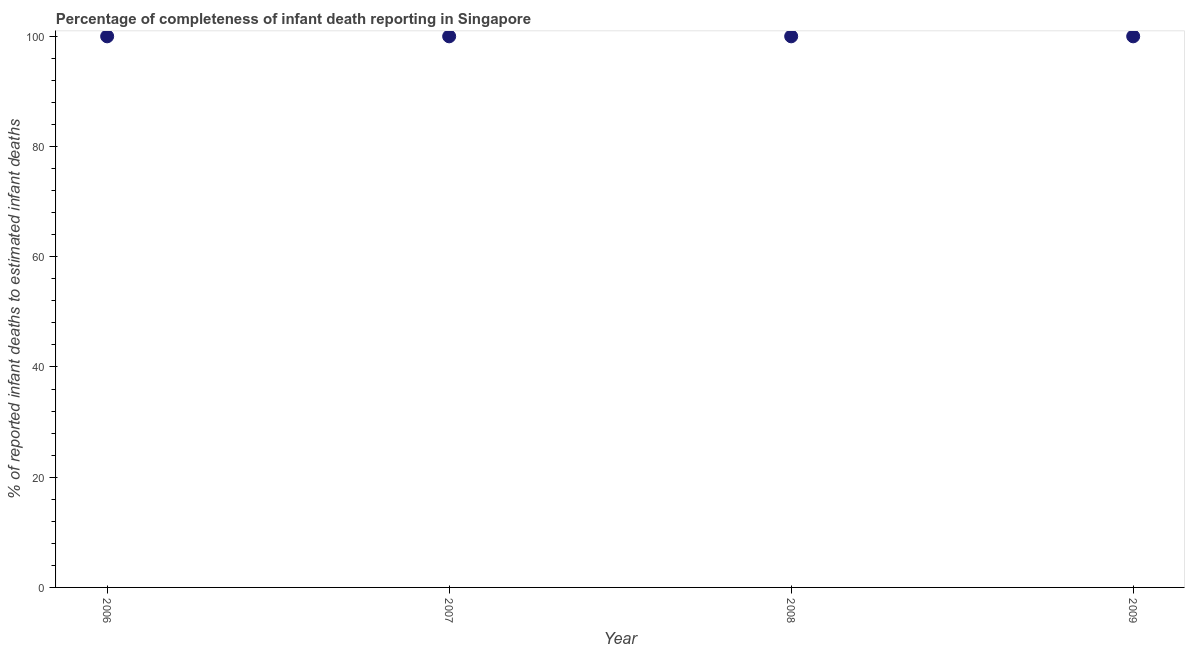What is the completeness of infant death reporting in 2008?
Offer a terse response. 100. Across all years, what is the maximum completeness of infant death reporting?
Your answer should be very brief. 100. Across all years, what is the minimum completeness of infant death reporting?
Provide a short and direct response. 100. In which year was the completeness of infant death reporting maximum?
Keep it short and to the point. 2006. What is the sum of the completeness of infant death reporting?
Make the answer very short. 400. What is the average completeness of infant death reporting per year?
Offer a terse response. 100. Is the difference between the completeness of infant death reporting in 2006 and 2007 greater than the difference between any two years?
Keep it short and to the point. Yes. What is the difference between the highest and the lowest completeness of infant death reporting?
Make the answer very short. 0. How many dotlines are there?
Your answer should be compact. 1. What is the difference between two consecutive major ticks on the Y-axis?
Ensure brevity in your answer.  20. What is the title of the graph?
Offer a terse response. Percentage of completeness of infant death reporting in Singapore. What is the label or title of the X-axis?
Your answer should be very brief. Year. What is the label or title of the Y-axis?
Provide a succinct answer. % of reported infant deaths to estimated infant deaths. What is the % of reported infant deaths to estimated infant deaths in 2008?
Offer a terse response. 100. What is the difference between the % of reported infant deaths to estimated infant deaths in 2006 and 2007?
Offer a very short reply. 0. What is the difference between the % of reported infant deaths to estimated infant deaths in 2006 and 2008?
Give a very brief answer. 0. What is the difference between the % of reported infant deaths to estimated infant deaths in 2006 and 2009?
Ensure brevity in your answer.  0. What is the difference between the % of reported infant deaths to estimated infant deaths in 2007 and 2008?
Keep it short and to the point. 0. What is the ratio of the % of reported infant deaths to estimated infant deaths in 2006 to that in 2007?
Ensure brevity in your answer.  1. What is the ratio of the % of reported infant deaths to estimated infant deaths in 2006 to that in 2008?
Keep it short and to the point. 1. What is the ratio of the % of reported infant deaths to estimated infant deaths in 2006 to that in 2009?
Your answer should be compact. 1. What is the ratio of the % of reported infant deaths to estimated infant deaths in 2007 to that in 2008?
Your answer should be very brief. 1. What is the ratio of the % of reported infant deaths to estimated infant deaths in 2007 to that in 2009?
Your answer should be compact. 1. What is the ratio of the % of reported infant deaths to estimated infant deaths in 2008 to that in 2009?
Provide a short and direct response. 1. 